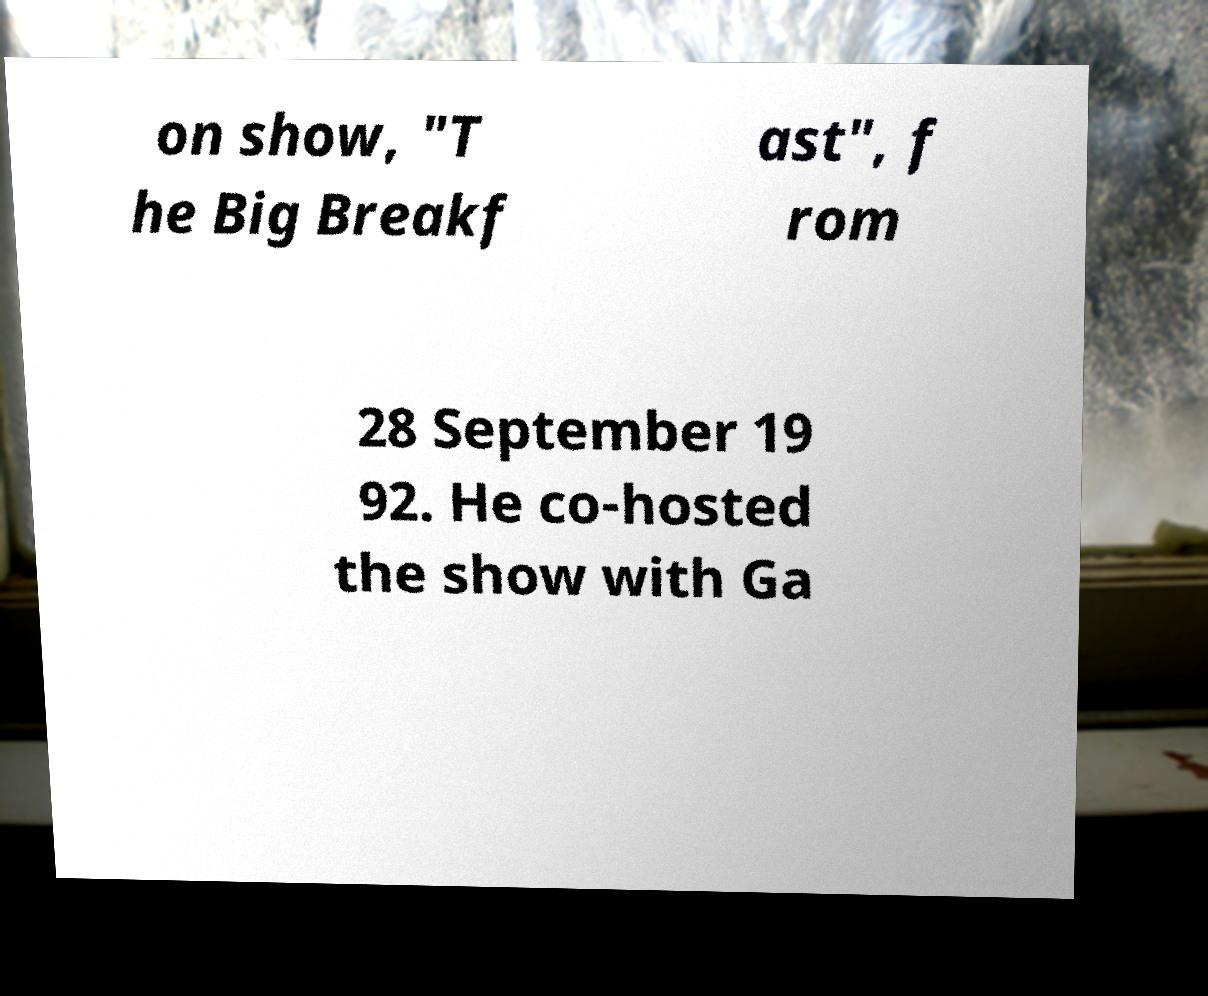Please read and relay the text visible in this image. What does it say? on show, "T he Big Breakf ast", f rom 28 September 19 92. He co-hosted the show with Ga 